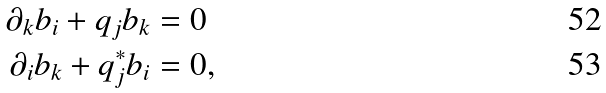<formula> <loc_0><loc_0><loc_500><loc_500>\partial _ { k } b _ { i } + q _ { j } b _ { k } & = 0 \\ \partial _ { i } b _ { k } + q _ { j } ^ { * } b _ { i } & = 0 ,</formula> 